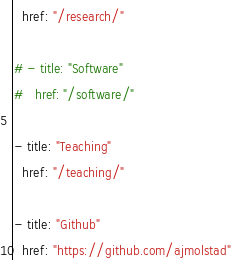<code> <loc_0><loc_0><loc_500><loc_500><_YAML_>  href: "/research/"

# - title: "Software"
#   href: "/software/"

- title: "Teaching"
  href: "/teaching/"

- title: "Github"
  href: "https://github.com/ajmolstad"</code> 